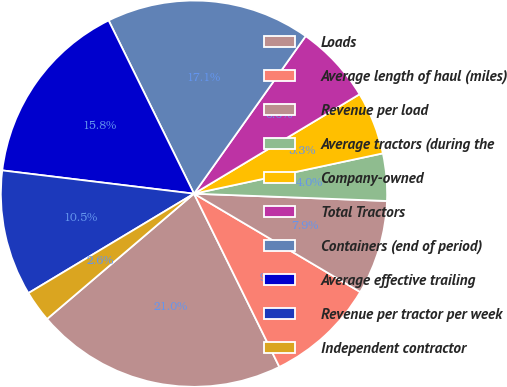Convert chart to OTSL. <chart><loc_0><loc_0><loc_500><loc_500><pie_chart><fcel>Loads<fcel>Average length of haul (miles)<fcel>Revenue per load<fcel>Average tractors (during the<fcel>Company-owned<fcel>Total Tractors<fcel>Containers (end of period)<fcel>Average effective trailing<fcel>Revenue per tractor per week<fcel>Independent contractor<nl><fcel>21.05%<fcel>9.21%<fcel>7.9%<fcel>3.95%<fcel>5.26%<fcel>6.58%<fcel>17.1%<fcel>15.79%<fcel>10.53%<fcel>2.63%<nl></chart> 